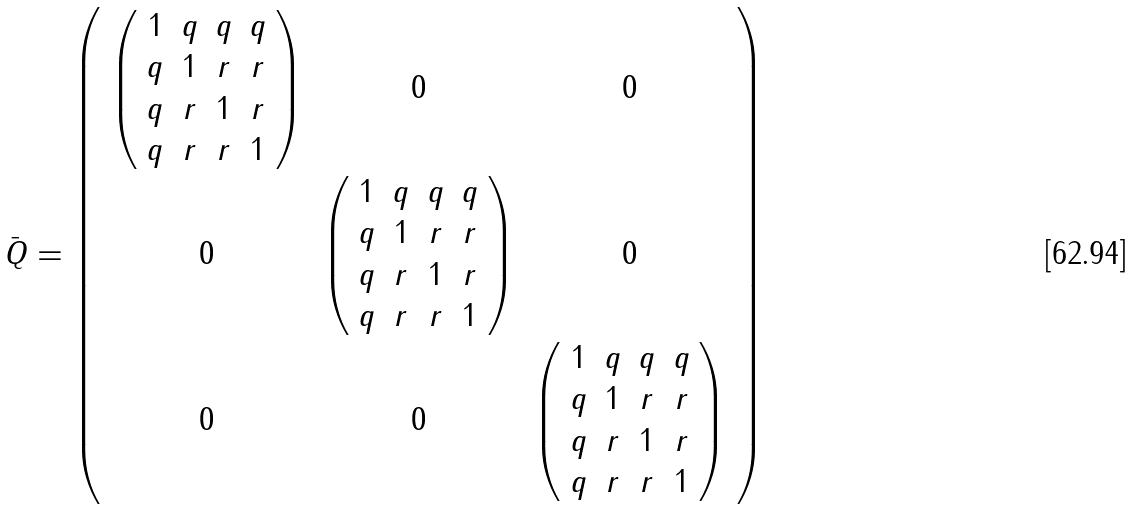Convert formula to latex. <formula><loc_0><loc_0><loc_500><loc_500>\bar { Q } = \left ( \begin{array} { c c c } \left ( \begin{array} { c c c c } 1 & q & q & q \\ q & 1 & r & r \\ q & r & 1 & r \\ q & r & r & 1 \\ \end{array} \right ) & 0 & 0 \\ 0 & \left ( \begin{array} { c c c c } 1 & q & q & q \\ q & 1 & r & r \\ q & r & 1 & r \\ q & r & r & 1 \\ \end{array} \right ) & 0 \\ 0 & 0 & \left ( \begin{array} { c c c c } 1 & q & q & q \\ q & 1 & r & r \\ q & r & 1 & r \\ q & r & r & 1 \\ \end{array} \right ) \\ \end{array} \right )</formula> 